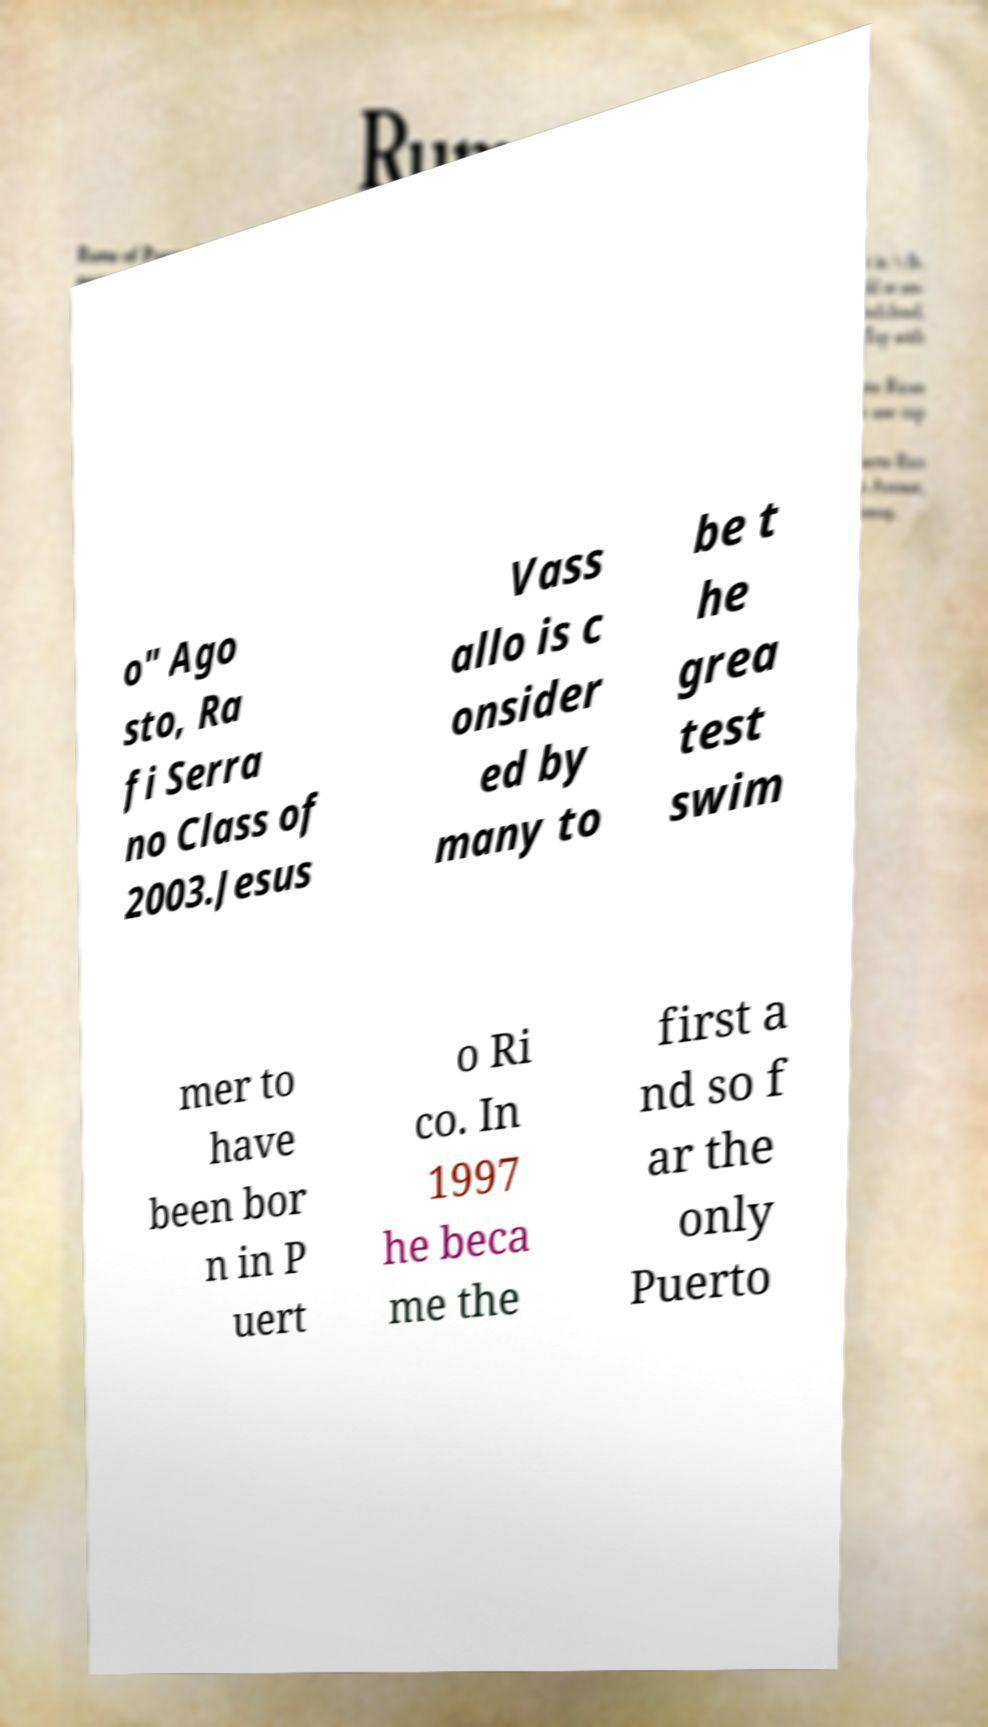Please read and relay the text visible in this image. What does it say? o" Ago sto, Ra fi Serra no Class of 2003.Jesus Vass allo is c onsider ed by many to be t he grea test swim mer to have been bor n in P uert o Ri co. In 1997 he beca me the first a nd so f ar the only Puerto 